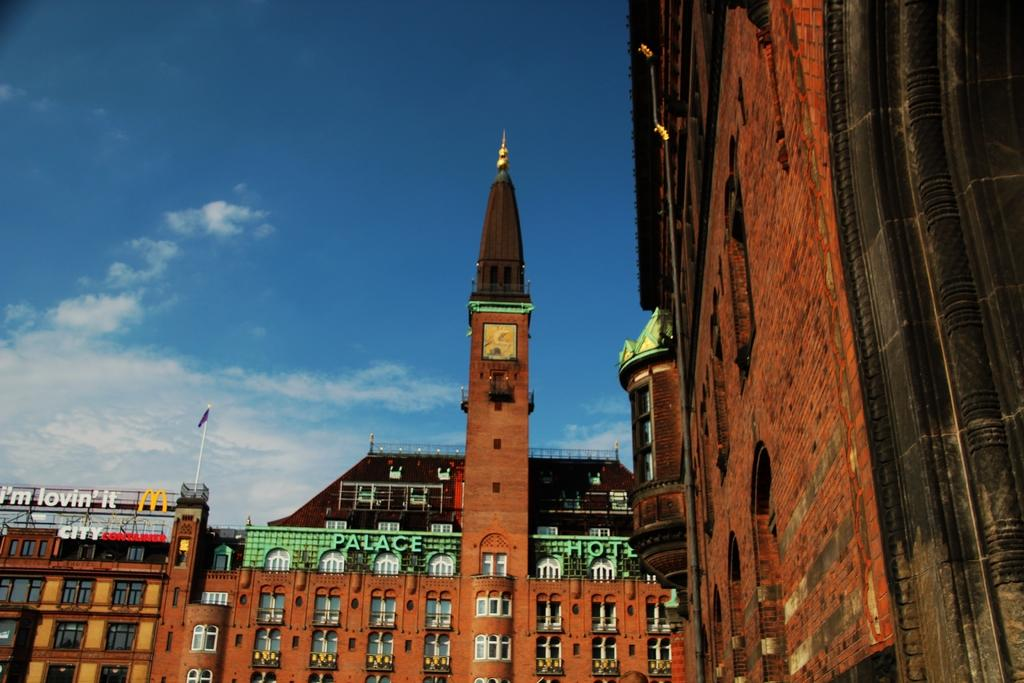What type of structures can be seen in the image? There are buildings in the image. What colors are the buildings? The buildings have black, brown, and white colors. What additional object is present in the image? There is a flag in the image. What can be seen in the background of the image? The sky is visible in the background of the image. What story does the mother tell about the buildings in the image? There is no mention of a mother or a story in the image, so we cannot answer this question. 